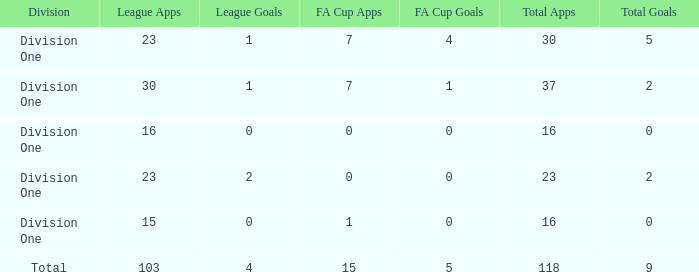What is the total number of apps when there are less than 4 fa cup goals and more than 7 fa cup apps? 0.0. 